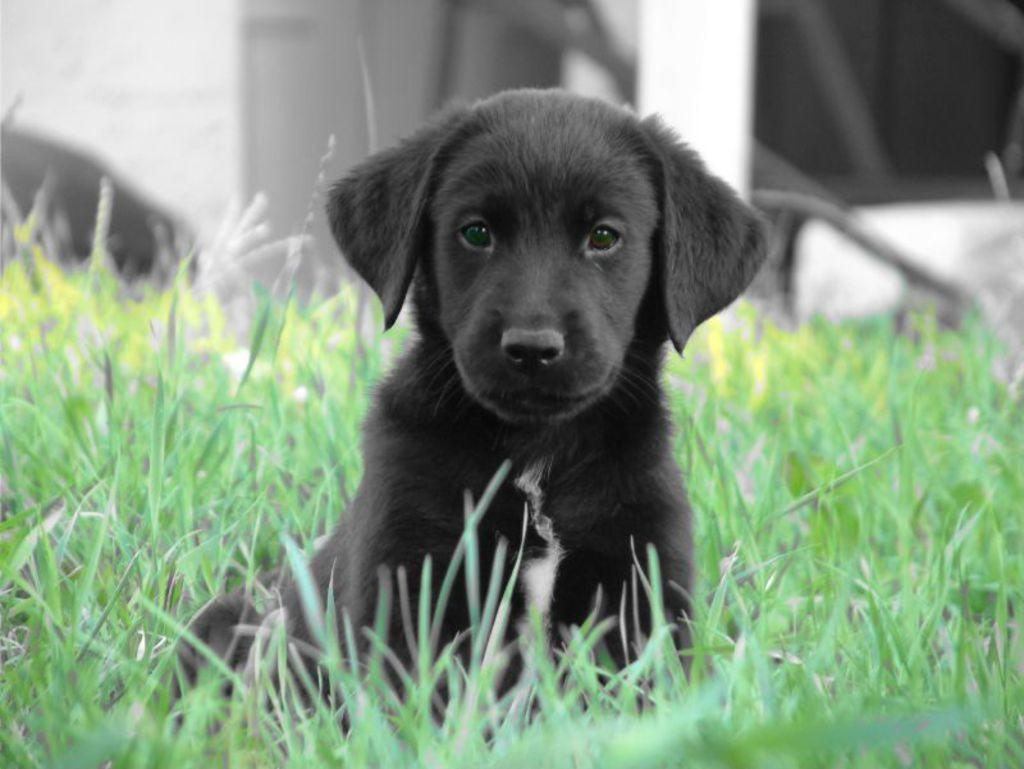What type of animal is in the foreground of the image? There is a black colored dog in the foreground of the image. What is the dog standing on? The dog is on the grass. Can you describe the background of the image? The background of the image is blurred. What type of cherry is the queen holding in the image? There is no cherry or queen present in the image; it features a black colored dog on the grass with a blurred background. 